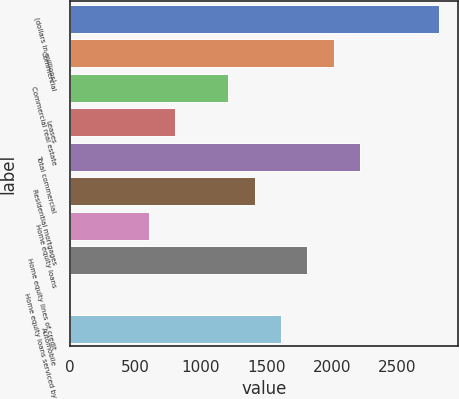Convert chart. <chart><loc_0><loc_0><loc_500><loc_500><bar_chart><fcel>(dollars in millions)<fcel>Commercial<fcel>Commercial real estate<fcel>Leases<fcel>Total commercial<fcel>Residential mortgages<fcel>Home equity loans<fcel>Home equity lines of credit<fcel>Home equity loans serviced by<fcel>Automobile<nl><fcel>2820.6<fcel>2015<fcel>1209.4<fcel>806.6<fcel>2216.4<fcel>1410.8<fcel>605.2<fcel>1813.6<fcel>1<fcel>1612.2<nl></chart> 